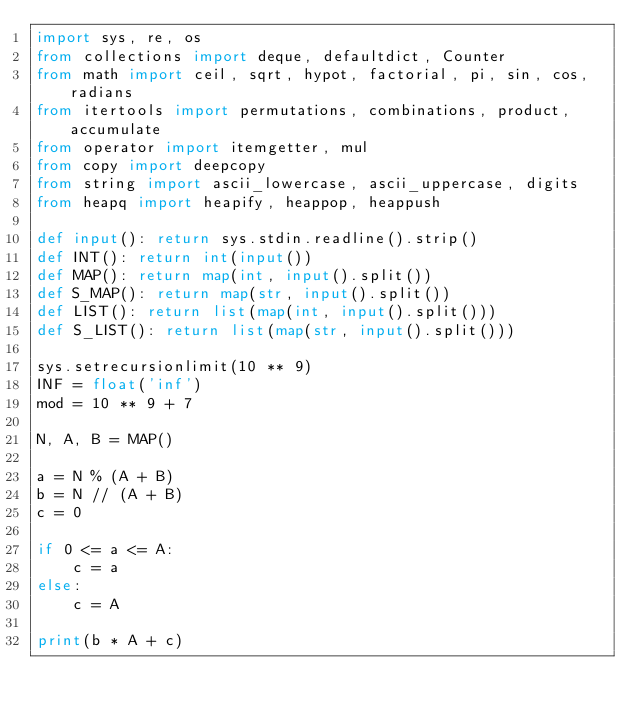Convert code to text. <code><loc_0><loc_0><loc_500><loc_500><_Python_>import sys, re, os
from collections import deque, defaultdict, Counter
from math import ceil, sqrt, hypot, factorial, pi, sin, cos, radians
from itertools import permutations, combinations, product, accumulate
from operator import itemgetter, mul
from copy import deepcopy
from string import ascii_lowercase, ascii_uppercase, digits
from heapq import heapify, heappop, heappush
 
def input(): return sys.stdin.readline().strip()
def INT(): return int(input())
def MAP(): return map(int, input().split())
def S_MAP(): return map(str, input().split())
def LIST(): return list(map(int, input().split()))
def S_LIST(): return list(map(str, input().split()))
 
sys.setrecursionlimit(10 ** 9)
INF = float('inf')
mod = 10 ** 9 + 7

N, A, B = MAP()

a = N % (A + B)
b = N // (A + B)
c = 0

if 0 <= a <= A:
    c = a
else:
    c = A

print(b * A + c)</code> 